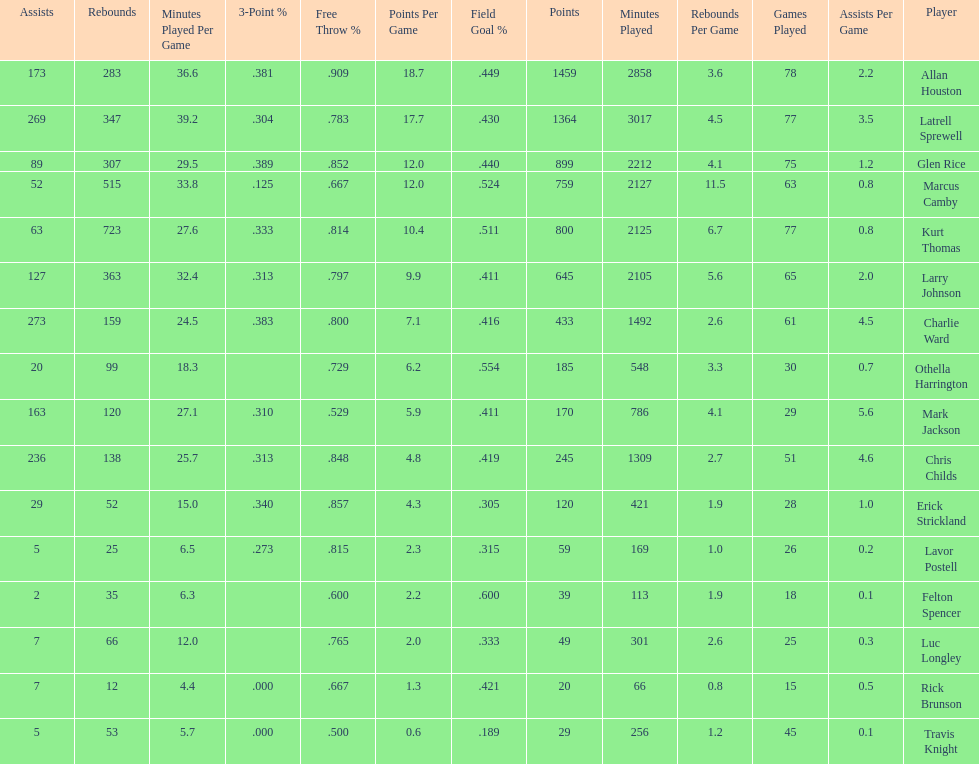How many games did larry johnson play? 65. 